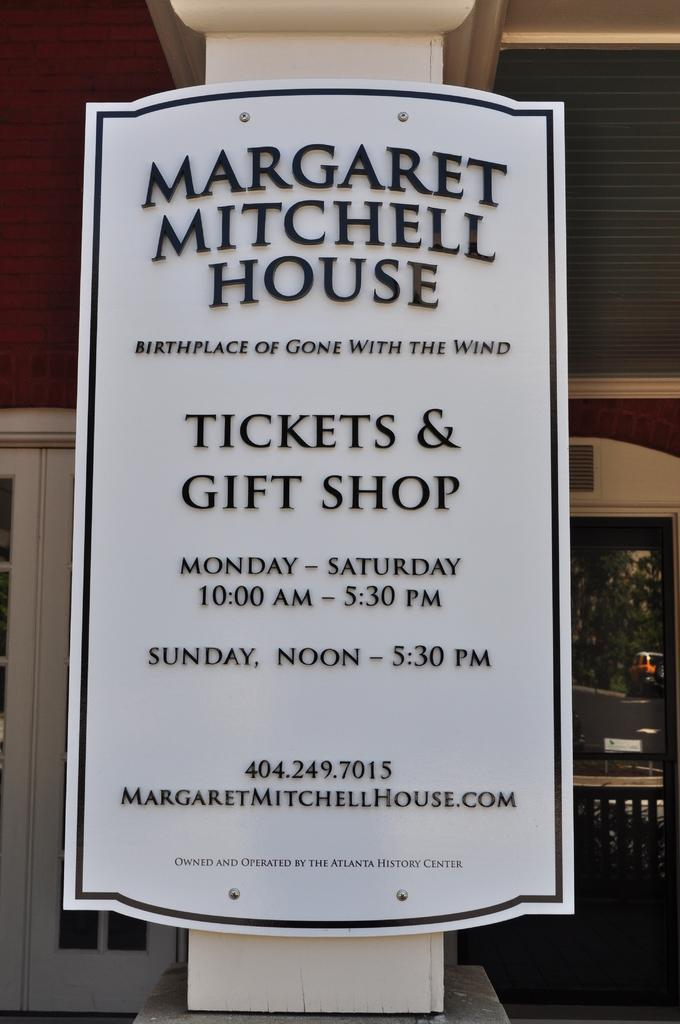What is written on the board in the image? There are texts written on a board in the image. Where is the board located? The board is on a platform. What can be seen in the background of the image? There are doors, glass, and a wall visible in the background of the image. What else is present in the background of the image? There are objects in the background of the image. Can you see a thumb in the image? There is no thumb present in the image. What type of flame can be seen coming from the objects in the background? There is no flame present in the image; the objects in the background do not emit any flames. 